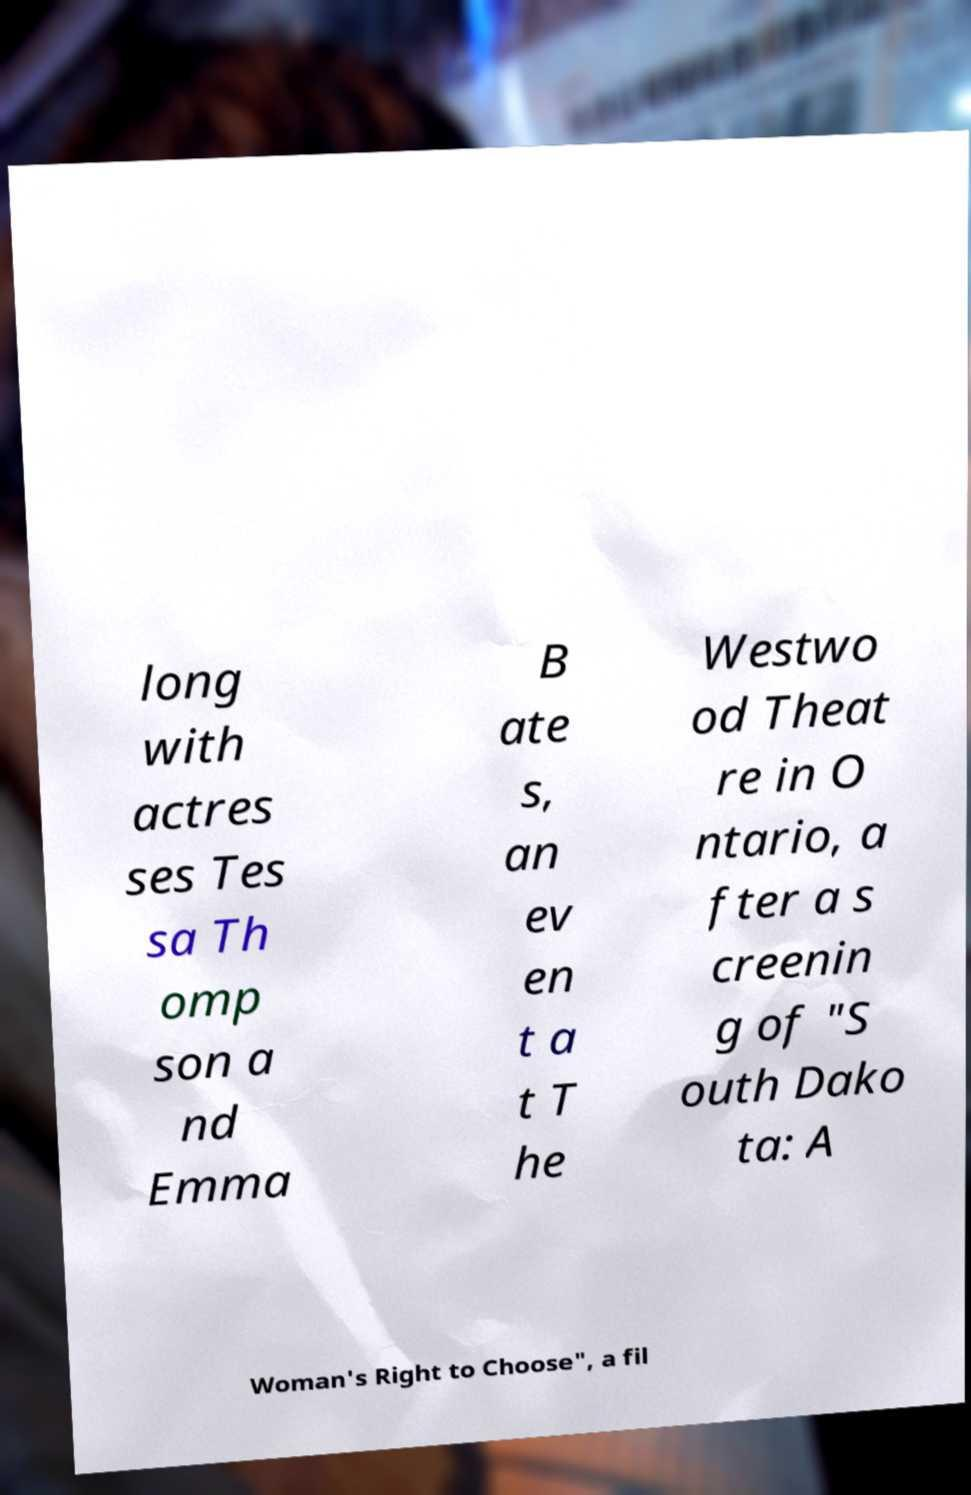Please identify and transcribe the text found in this image. long with actres ses Tes sa Th omp son a nd Emma B ate s, an ev en t a t T he Westwo od Theat re in O ntario, a fter a s creenin g of "S outh Dako ta: A Woman's Right to Choose", a fil 